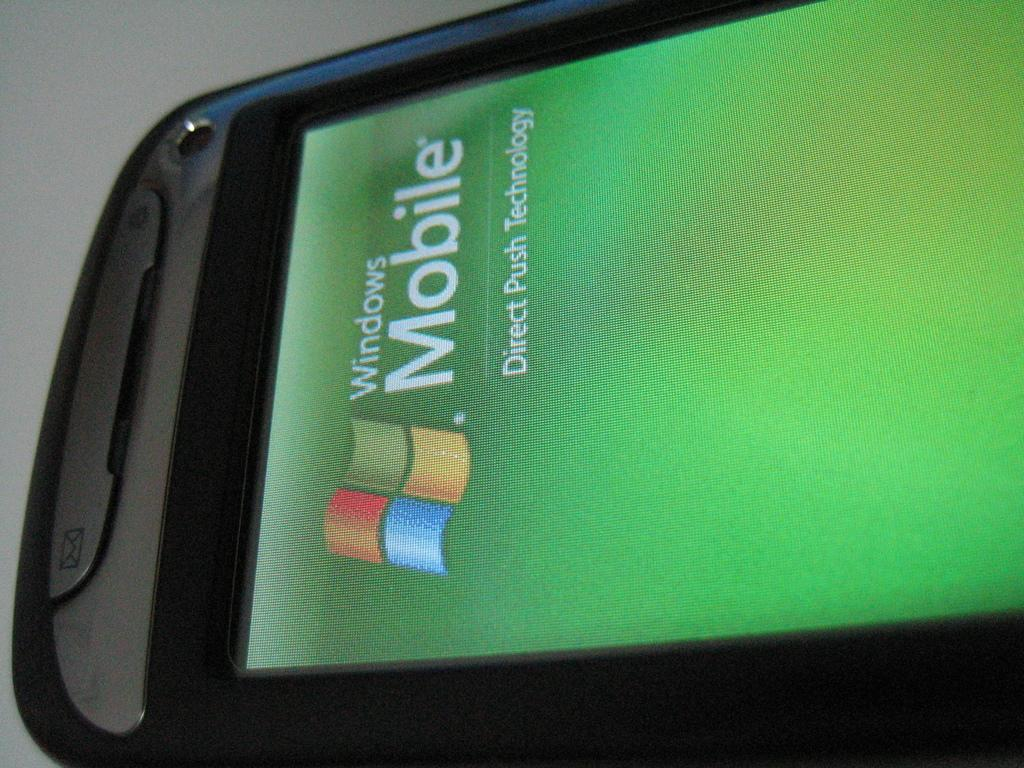<image>
Share a concise interpretation of the image provided. The program that is shown on the phone is part of the Windows Mobile technology. 